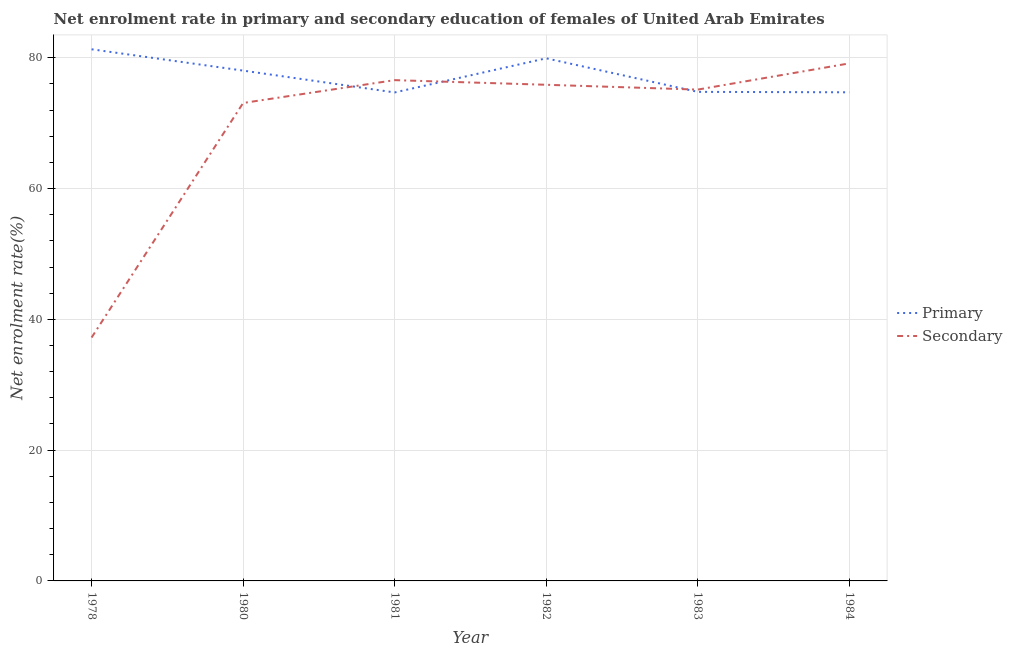Is the number of lines equal to the number of legend labels?
Make the answer very short. Yes. What is the enrollment rate in secondary education in 1980?
Provide a succinct answer. 73.08. Across all years, what is the maximum enrollment rate in primary education?
Give a very brief answer. 81.29. Across all years, what is the minimum enrollment rate in primary education?
Your response must be concise. 74.7. In which year was the enrollment rate in secondary education minimum?
Give a very brief answer. 1978. What is the total enrollment rate in primary education in the graph?
Your answer should be compact. 463.44. What is the difference between the enrollment rate in secondary education in 1982 and that in 1983?
Ensure brevity in your answer.  0.74. What is the difference between the enrollment rate in secondary education in 1978 and the enrollment rate in primary education in 1982?
Your answer should be compact. -42.7. What is the average enrollment rate in secondary education per year?
Your answer should be compact. 69.5. In the year 1983, what is the difference between the enrollment rate in primary education and enrollment rate in secondary education?
Your answer should be compact. -0.35. In how many years, is the enrollment rate in secondary education greater than 64 %?
Your response must be concise. 5. What is the ratio of the enrollment rate in secondary education in 1980 to that in 1981?
Your answer should be compact. 0.95. What is the difference between the highest and the second highest enrollment rate in primary education?
Make the answer very short. 1.38. What is the difference between the highest and the lowest enrollment rate in primary education?
Ensure brevity in your answer.  6.6. In how many years, is the enrollment rate in secondary education greater than the average enrollment rate in secondary education taken over all years?
Provide a short and direct response. 5. Is the enrollment rate in secondary education strictly greater than the enrollment rate in primary education over the years?
Provide a short and direct response. No. How many lines are there?
Keep it short and to the point. 2. What is the difference between two consecutive major ticks on the Y-axis?
Give a very brief answer. 20. Does the graph contain any zero values?
Offer a terse response. No. How many legend labels are there?
Provide a succinct answer. 2. How are the legend labels stacked?
Give a very brief answer. Vertical. What is the title of the graph?
Keep it short and to the point. Net enrolment rate in primary and secondary education of females of United Arab Emirates. Does "Highest 20% of population" appear as one of the legend labels in the graph?
Ensure brevity in your answer.  No. What is the label or title of the Y-axis?
Keep it short and to the point. Net enrolment rate(%). What is the Net enrolment rate(%) in Primary in 1978?
Give a very brief answer. 81.29. What is the Net enrolment rate(%) in Secondary in 1978?
Ensure brevity in your answer.  37.22. What is the Net enrolment rate(%) in Primary in 1980?
Ensure brevity in your answer.  78.03. What is the Net enrolment rate(%) in Secondary in 1980?
Your answer should be very brief. 73.08. What is the Net enrolment rate(%) in Primary in 1981?
Provide a short and direct response. 74.7. What is the Net enrolment rate(%) of Secondary in 1981?
Your answer should be compact. 76.58. What is the Net enrolment rate(%) in Primary in 1982?
Give a very brief answer. 79.92. What is the Net enrolment rate(%) of Secondary in 1982?
Give a very brief answer. 75.87. What is the Net enrolment rate(%) of Primary in 1983?
Provide a succinct answer. 74.78. What is the Net enrolment rate(%) in Secondary in 1983?
Ensure brevity in your answer.  75.13. What is the Net enrolment rate(%) in Primary in 1984?
Offer a very short reply. 74.72. What is the Net enrolment rate(%) in Secondary in 1984?
Your answer should be very brief. 79.14. Across all years, what is the maximum Net enrolment rate(%) in Primary?
Keep it short and to the point. 81.29. Across all years, what is the maximum Net enrolment rate(%) of Secondary?
Your answer should be compact. 79.14. Across all years, what is the minimum Net enrolment rate(%) in Primary?
Your answer should be very brief. 74.7. Across all years, what is the minimum Net enrolment rate(%) of Secondary?
Your answer should be compact. 37.22. What is the total Net enrolment rate(%) of Primary in the graph?
Offer a terse response. 463.44. What is the total Net enrolment rate(%) of Secondary in the graph?
Your response must be concise. 417.01. What is the difference between the Net enrolment rate(%) of Primary in 1978 and that in 1980?
Provide a succinct answer. 3.26. What is the difference between the Net enrolment rate(%) in Secondary in 1978 and that in 1980?
Ensure brevity in your answer.  -35.87. What is the difference between the Net enrolment rate(%) of Primary in 1978 and that in 1981?
Your response must be concise. 6.6. What is the difference between the Net enrolment rate(%) of Secondary in 1978 and that in 1981?
Give a very brief answer. -39.36. What is the difference between the Net enrolment rate(%) of Primary in 1978 and that in 1982?
Provide a succinct answer. 1.38. What is the difference between the Net enrolment rate(%) in Secondary in 1978 and that in 1982?
Your answer should be very brief. -38.65. What is the difference between the Net enrolment rate(%) in Primary in 1978 and that in 1983?
Your answer should be very brief. 6.51. What is the difference between the Net enrolment rate(%) of Secondary in 1978 and that in 1983?
Provide a succinct answer. -37.91. What is the difference between the Net enrolment rate(%) in Primary in 1978 and that in 1984?
Provide a succinct answer. 6.58. What is the difference between the Net enrolment rate(%) of Secondary in 1978 and that in 1984?
Your response must be concise. -41.92. What is the difference between the Net enrolment rate(%) in Primary in 1980 and that in 1981?
Keep it short and to the point. 3.34. What is the difference between the Net enrolment rate(%) of Secondary in 1980 and that in 1981?
Keep it short and to the point. -3.49. What is the difference between the Net enrolment rate(%) of Primary in 1980 and that in 1982?
Offer a terse response. -1.88. What is the difference between the Net enrolment rate(%) of Secondary in 1980 and that in 1982?
Your response must be concise. -2.78. What is the difference between the Net enrolment rate(%) of Primary in 1980 and that in 1983?
Your answer should be very brief. 3.25. What is the difference between the Net enrolment rate(%) in Secondary in 1980 and that in 1983?
Make the answer very short. -2.05. What is the difference between the Net enrolment rate(%) of Primary in 1980 and that in 1984?
Your answer should be very brief. 3.32. What is the difference between the Net enrolment rate(%) in Secondary in 1980 and that in 1984?
Provide a short and direct response. -6.05. What is the difference between the Net enrolment rate(%) in Primary in 1981 and that in 1982?
Your answer should be compact. -5.22. What is the difference between the Net enrolment rate(%) in Secondary in 1981 and that in 1982?
Ensure brevity in your answer.  0.71. What is the difference between the Net enrolment rate(%) in Primary in 1981 and that in 1983?
Your answer should be very brief. -0.09. What is the difference between the Net enrolment rate(%) of Secondary in 1981 and that in 1983?
Offer a terse response. 1.44. What is the difference between the Net enrolment rate(%) of Primary in 1981 and that in 1984?
Make the answer very short. -0.02. What is the difference between the Net enrolment rate(%) in Secondary in 1981 and that in 1984?
Give a very brief answer. -2.56. What is the difference between the Net enrolment rate(%) of Primary in 1982 and that in 1983?
Ensure brevity in your answer.  5.13. What is the difference between the Net enrolment rate(%) of Secondary in 1982 and that in 1983?
Your response must be concise. 0.74. What is the difference between the Net enrolment rate(%) of Primary in 1982 and that in 1984?
Ensure brevity in your answer.  5.2. What is the difference between the Net enrolment rate(%) in Secondary in 1982 and that in 1984?
Give a very brief answer. -3.27. What is the difference between the Net enrolment rate(%) in Primary in 1983 and that in 1984?
Offer a very short reply. 0.07. What is the difference between the Net enrolment rate(%) in Secondary in 1983 and that in 1984?
Make the answer very short. -4.01. What is the difference between the Net enrolment rate(%) in Primary in 1978 and the Net enrolment rate(%) in Secondary in 1980?
Offer a terse response. 8.21. What is the difference between the Net enrolment rate(%) of Primary in 1978 and the Net enrolment rate(%) of Secondary in 1981?
Make the answer very short. 4.72. What is the difference between the Net enrolment rate(%) of Primary in 1978 and the Net enrolment rate(%) of Secondary in 1982?
Your answer should be very brief. 5.43. What is the difference between the Net enrolment rate(%) of Primary in 1978 and the Net enrolment rate(%) of Secondary in 1983?
Provide a short and direct response. 6.16. What is the difference between the Net enrolment rate(%) of Primary in 1978 and the Net enrolment rate(%) of Secondary in 1984?
Offer a very short reply. 2.16. What is the difference between the Net enrolment rate(%) of Primary in 1980 and the Net enrolment rate(%) of Secondary in 1981?
Ensure brevity in your answer.  1.46. What is the difference between the Net enrolment rate(%) in Primary in 1980 and the Net enrolment rate(%) in Secondary in 1982?
Provide a short and direct response. 2.17. What is the difference between the Net enrolment rate(%) in Primary in 1980 and the Net enrolment rate(%) in Secondary in 1983?
Provide a short and direct response. 2.9. What is the difference between the Net enrolment rate(%) of Primary in 1980 and the Net enrolment rate(%) of Secondary in 1984?
Your response must be concise. -1.1. What is the difference between the Net enrolment rate(%) in Primary in 1981 and the Net enrolment rate(%) in Secondary in 1982?
Your answer should be compact. -1.17. What is the difference between the Net enrolment rate(%) in Primary in 1981 and the Net enrolment rate(%) in Secondary in 1983?
Give a very brief answer. -0.44. What is the difference between the Net enrolment rate(%) in Primary in 1981 and the Net enrolment rate(%) in Secondary in 1984?
Your answer should be compact. -4.44. What is the difference between the Net enrolment rate(%) of Primary in 1982 and the Net enrolment rate(%) of Secondary in 1983?
Your answer should be very brief. 4.78. What is the difference between the Net enrolment rate(%) in Primary in 1982 and the Net enrolment rate(%) in Secondary in 1984?
Offer a terse response. 0.78. What is the difference between the Net enrolment rate(%) of Primary in 1983 and the Net enrolment rate(%) of Secondary in 1984?
Offer a very short reply. -4.35. What is the average Net enrolment rate(%) of Primary per year?
Offer a terse response. 77.24. What is the average Net enrolment rate(%) of Secondary per year?
Your response must be concise. 69.5. In the year 1978, what is the difference between the Net enrolment rate(%) in Primary and Net enrolment rate(%) in Secondary?
Provide a short and direct response. 44.08. In the year 1980, what is the difference between the Net enrolment rate(%) in Primary and Net enrolment rate(%) in Secondary?
Offer a very short reply. 4.95. In the year 1981, what is the difference between the Net enrolment rate(%) in Primary and Net enrolment rate(%) in Secondary?
Provide a short and direct response. -1.88. In the year 1982, what is the difference between the Net enrolment rate(%) of Primary and Net enrolment rate(%) of Secondary?
Provide a succinct answer. 4.05. In the year 1983, what is the difference between the Net enrolment rate(%) of Primary and Net enrolment rate(%) of Secondary?
Offer a very short reply. -0.35. In the year 1984, what is the difference between the Net enrolment rate(%) in Primary and Net enrolment rate(%) in Secondary?
Offer a terse response. -4.42. What is the ratio of the Net enrolment rate(%) in Primary in 1978 to that in 1980?
Your answer should be very brief. 1.04. What is the ratio of the Net enrolment rate(%) of Secondary in 1978 to that in 1980?
Your answer should be very brief. 0.51. What is the ratio of the Net enrolment rate(%) in Primary in 1978 to that in 1981?
Your answer should be compact. 1.09. What is the ratio of the Net enrolment rate(%) of Secondary in 1978 to that in 1981?
Give a very brief answer. 0.49. What is the ratio of the Net enrolment rate(%) of Primary in 1978 to that in 1982?
Give a very brief answer. 1.02. What is the ratio of the Net enrolment rate(%) in Secondary in 1978 to that in 1982?
Your answer should be very brief. 0.49. What is the ratio of the Net enrolment rate(%) in Primary in 1978 to that in 1983?
Provide a short and direct response. 1.09. What is the ratio of the Net enrolment rate(%) in Secondary in 1978 to that in 1983?
Make the answer very short. 0.5. What is the ratio of the Net enrolment rate(%) in Primary in 1978 to that in 1984?
Ensure brevity in your answer.  1.09. What is the ratio of the Net enrolment rate(%) of Secondary in 1978 to that in 1984?
Offer a very short reply. 0.47. What is the ratio of the Net enrolment rate(%) of Primary in 1980 to that in 1981?
Your answer should be compact. 1.04. What is the ratio of the Net enrolment rate(%) of Secondary in 1980 to that in 1981?
Offer a very short reply. 0.95. What is the ratio of the Net enrolment rate(%) of Primary in 1980 to that in 1982?
Your answer should be compact. 0.98. What is the ratio of the Net enrolment rate(%) of Secondary in 1980 to that in 1982?
Keep it short and to the point. 0.96. What is the ratio of the Net enrolment rate(%) in Primary in 1980 to that in 1983?
Keep it short and to the point. 1.04. What is the ratio of the Net enrolment rate(%) in Secondary in 1980 to that in 1983?
Your answer should be very brief. 0.97. What is the ratio of the Net enrolment rate(%) in Primary in 1980 to that in 1984?
Give a very brief answer. 1.04. What is the ratio of the Net enrolment rate(%) in Secondary in 1980 to that in 1984?
Your answer should be compact. 0.92. What is the ratio of the Net enrolment rate(%) in Primary in 1981 to that in 1982?
Your response must be concise. 0.93. What is the ratio of the Net enrolment rate(%) of Secondary in 1981 to that in 1982?
Offer a very short reply. 1.01. What is the ratio of the Net enrolment rate(%) of Primary in 1981 to that in 1983?
Your answer should be very brief. 1. What is the ratio of the Net enrolment rate(%) in Secondary in 1981 to that in 1983?
Keep it short and to the point. 1.02. What is the ratio of the Net enrolment rate(%) in Secondary in 1981 to that in 1984?
Your response must be concise. 0.97. What is the ratio of the Net enrolment rate(%) of Primary in 1982 to that in 1983?
Offer a very short reply. 1.07. What is the ratio of the Net enrolment rate(%) in Secondary in 1982 to that in 1983?
Your response must be concise. 1.01. What is the ratio of the Net enrolment rate(%) in Primary in 1982 to that in 1984?
Give a very brief answer. 1.07. What is the ratio of the Net enrolment rate(%) in Secondary in 1982 to that in 1984?
Keep it short and to the point. 0.96. What is the ratio of the Net enrolment rate(%) of Primary in 1983 to that in 1984?
Your answer should be compact. 1. What is the ratio of the Net enrolment rate(%) of Secondary in 1983 to that in 1984?
Provide a succinct answer. 0.95. What is the difference between the highest and the second highest Net enrolment rate(%) in Primary?
Offer a terse response. 1.38. What is the difference between the highest and the second highest Net enrolment rate(%) in Secondary?
Keep it short and to the point. 2.56. What is the difference between the highest and the lowest Net enrolment rate(%) in Primary?
Your answer should be very brief. 6.6. What is the difference between the highest and the lowest Net enrolment rate(%) of Secondary?
Your answer should be very brief. 41.92. 